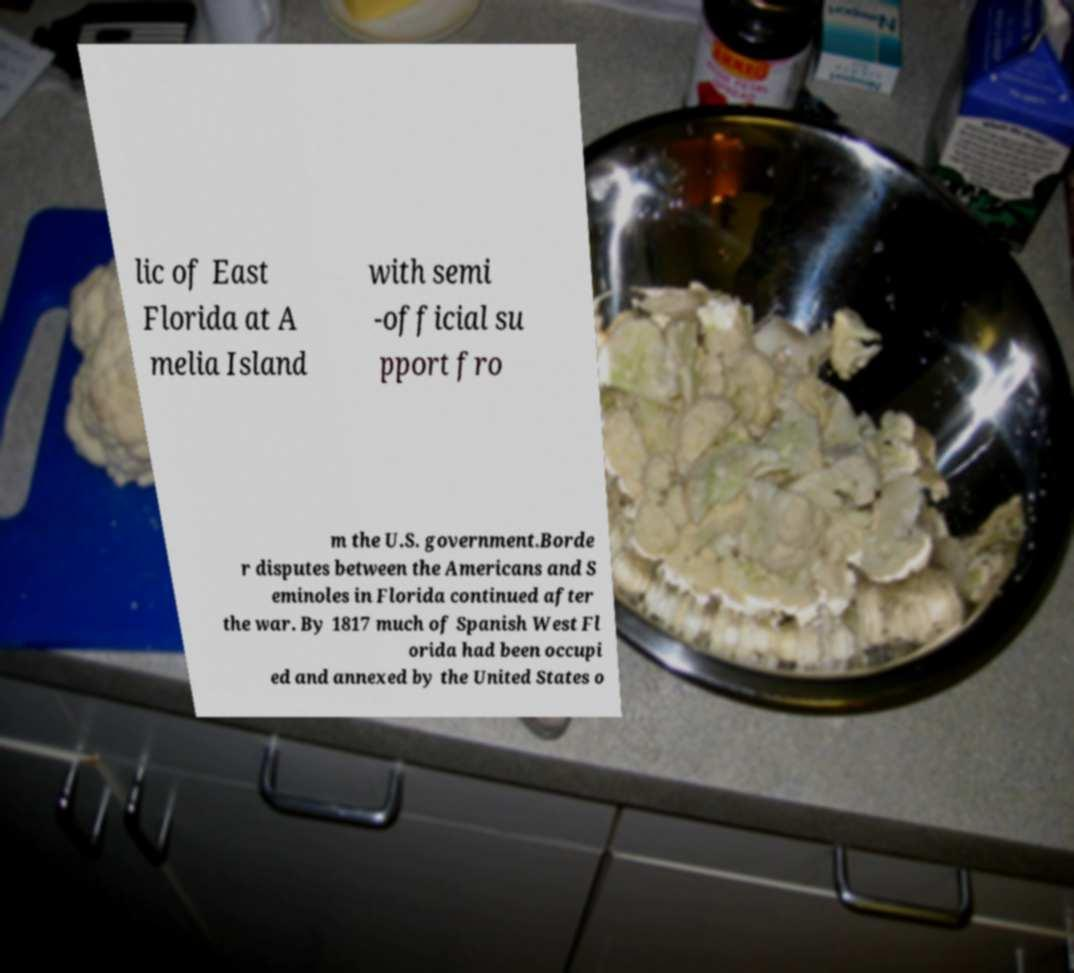I need the written content from this picture converted into text. Can you do that? lic of East Florida at A melia Island with semi -official su pport fro m the U.S. government.Borde r disputes between the Americans and S eminoles in Florida continued after the war. By 1817 much of Spanish West Fl orida had been occupi ed and annexed by the United States o 